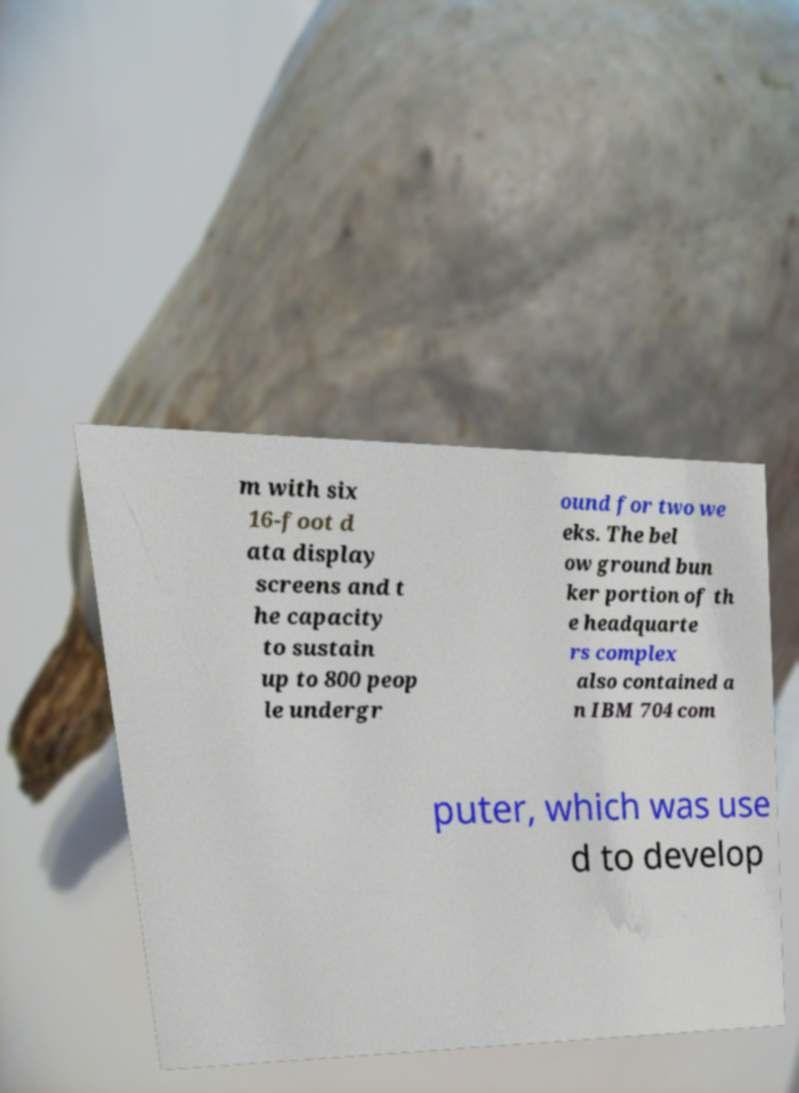Could you assist in decoding the text presented in this image and type it out clearly? m with six 16-foot d ata display screens and t he capacity to sustain up to 800 peop le undergr ound for two we eks. The bel ow ground bun ker portion of th e headquarte rs complex also contained a n IBM 704 com puter, which was use d to develop 